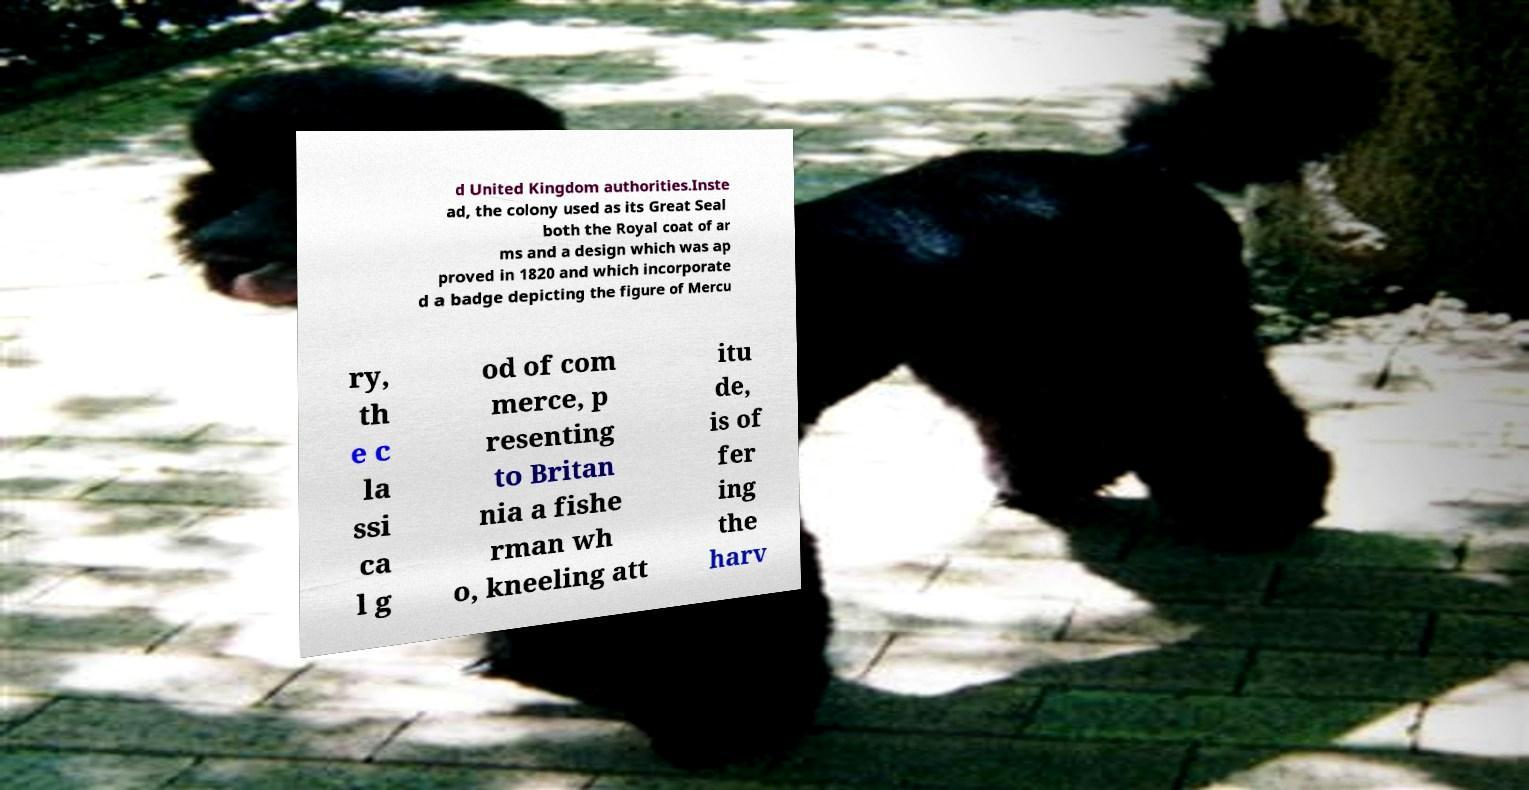For documentation purposes, I need the text within this image transcribed. Could you provide that? d United Kingdom authorities.Inste ad, the colony used as its Great Seal both the Royal coat of ar ms and a design which was ap proved in 1820 and which incorporate d a badge depicting the figure of Mercu ry, th e c la ssi ca l g od of com merce, p resenting to Britan nia a fishe rman wh o, kneeling att itu de, is of fer ing the harv 